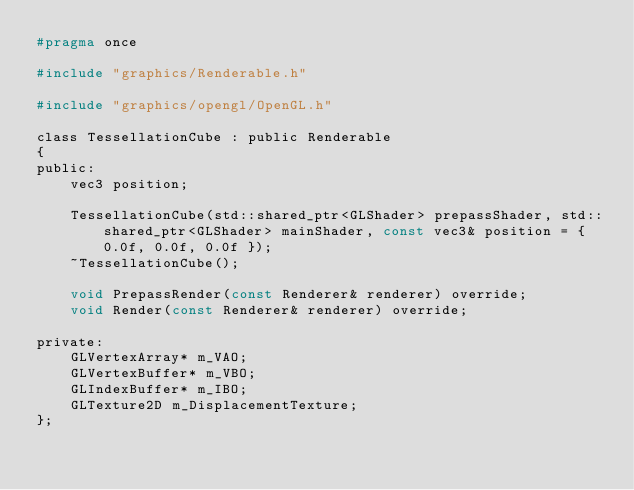<code> <loc_0><loc_0><loc_500><loc_500><_C_>#pragma once

#include "graphics/Renderable.h"

#include "graphics/opengl/OpenGL.h"

class TessellationCube : public Renderable
{
public:
	vec3 position;

	TessellationCube(std::shared_ptr<GLShader> prepassShader, std::shared_ptr<GLShader> mainShader, const vec3& position = { 0.0f, 0.0f, 0.0f });
	~TessellationCube();

	void PrepassRender(const Renderer& renderer) override;
	void Render(const Renderer& renderer) override;

private:
	GLVertexArray* m_VAO;
	GLVertexBuffer* m_VBO;
	GLIndexBuffer* m_IBO;
	GLTexture2D m_DisplacementTexture;
};</code> 